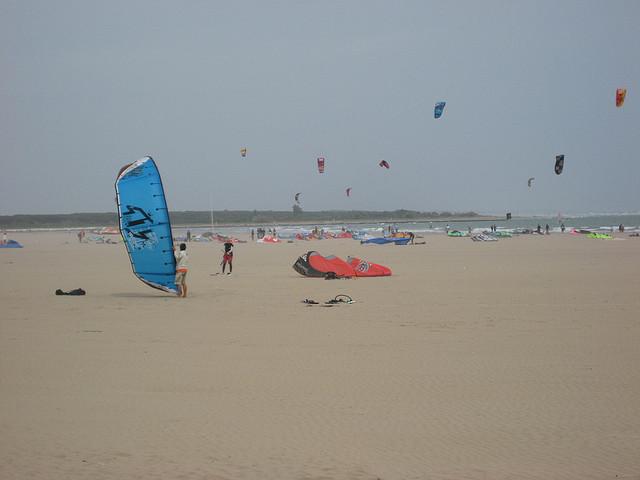What is the person doing?
Quick response, please. Kiting. Are all the people swimming?
Give a very brief answer. No. See footprints in the sand?
Keep it brief. No. How many people?
Quick response, please. 2. Where are the kites flying above?
Quick response, please. Beach. Is it a windy enough day for kite flying?
Write a very short answer. Yes. Are there large buildings in the background?
Be succinct. No. What color is the sky?
Short answer required. Blue. Are these people hang gliding?
Quick response, please. No. 